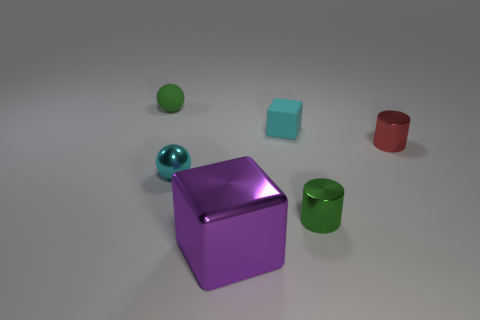Subtract all purple cubes. How many cubes are left? 1 Subtract 1 cubes. How many cubes are left? 1 Add 2 gray rubber balls. How many objects exist? 8 Subtract all cylinders. How many objects are left? 4 Subtract all yellow blocks. Subtract all cyan balls. How many blocks are left? 2 Subtract all tiny cyan rubber objects. Subtract all cyan metal objects. How many objects are left? 4 Add 3 small cubes. How many small cubes are left? 4 Add 1 big purple things. How many big purple things exist? 2 Subtract 0 yellow cylinders. How many objects are left? 6 